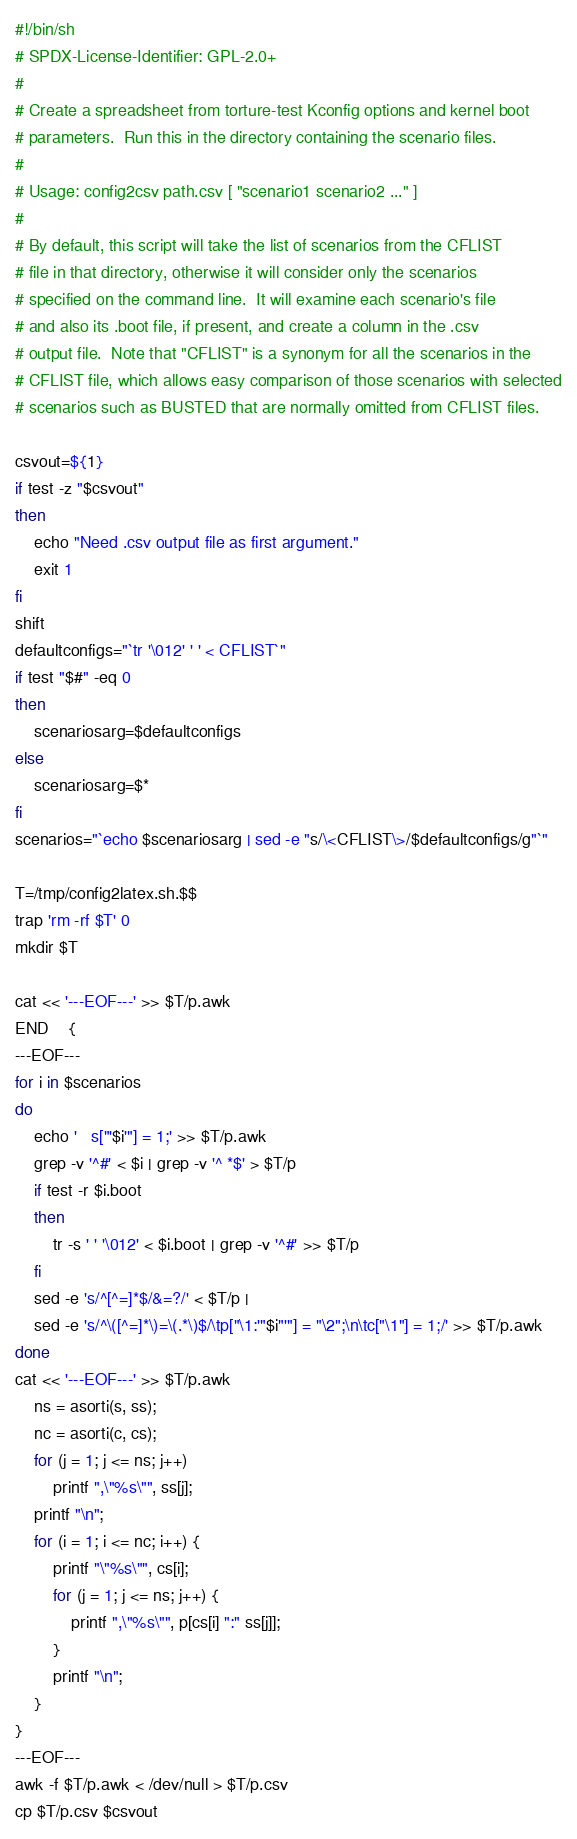<code> <loc_0><loc_0><loc_500><loc_500><_Bash_>#!/bin/sh
# SPDX-License-Identifier: GPL-2.0+
#
# Create a spreadsheet from torture-test Kconfig options and kernel boot
# parameters.  Run this in the directory containing the scenario files.
#
# Usage: config2csv path.csv [ "scenario1 scenario2 ..." ]
#
# By default, this script will take the list of scenarios from the CFLIST
# file in that directory, otherwise it will consider only the scenarios
# specified on the command line.  It will examine each scenario's file
# and also its .boot file, if present, and create a column in the .csv
# output file.  Note that "CFLIST" is a synonym for all the scenarios in the
# CFLIST file, which allows easy comparison of those scenarios with selected
# scenarios such as BUSTED that are normally omitted from CFLIST files.

csvout=${1}
if test -z "$csvout"
then
	echo "Need .csv output file as first argument."
	exit 1
fi
shift
defaultconfigs="`tr '\012' ' ' < CFLIST`"
if test "$#" -eq 0
then
	scenariosarg=$defaultconfigs
else
	scenariosarg=$*
fi
scenarios="`echo $scenariosarg | sed -e "s/\<CFLIST\>/$defaultconfigs/g"`"

T=/tmp/config2latex.sh.$$
trap 'rm -rf $T' 0
mkdir $T

cat << '---EOF---' >> $T/p.awk
END	{
---EOF---
for i in $scenarios
do
	echo '	s["'$i'"] = 1;' >> $T/p.awk
	grep -v '^#' < $i | grep -v '^ *$' > $T/p
	if test -r $i.boot
	then
		tr -s ' ' '\012' < $i.boot | grep -v '^#' >> $T/p
	fi
	sed -e 's/^[^=]*$/&=?/' < $T/p |
	sed -e 's/^\([^=]*\)=\(.*\)$/\tp["\1:'"$i"'"] = "\2";\n\tc["\1"] = 1;/' >> $T/p.awk
done
cat << '---EOF---' >> $T/p.awk
	ns = asorti(s, ss);
	nc = asorti(c, cs);
	for (j = 1; j <= ns; j++)
		printf ",\"%s\"", ss[j];
	printf "\n";
	for (i = 1; i <= nc; i++) {
		printf "\"%s\"", cs[i];
		for (j = 1; j <= ns; j++) {
			printf ",\"%s\"", p[cs[i] ":" ss[j]];
		}
		printf "\n";
	}
}
---EOF---
awk -f $T/p.awk < /dev/null > $T/p.csv
cp $T/p.csv $csvout
</code> 